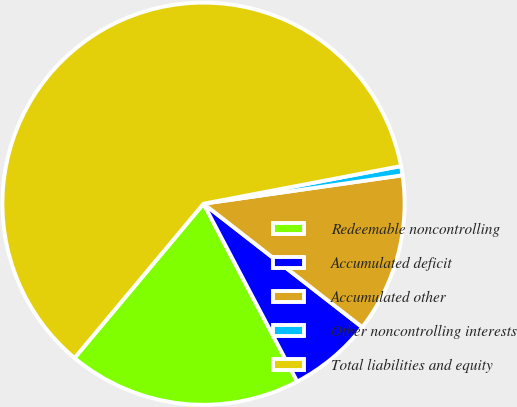Convert chart. <chart><loc_0><loc_0><loc_500><loc_500><pie_chart><fcel>Redeemable noncontrolling<fcel>Accumulated deficit<fcel>Accumulated other<fcel>Other noncontrolling interests<fcel>Total liabilities and equity<nl><fcel>18.8%<fcel>6.76%<fcel>12.78%<fcel>0.74%<fcel>60.92%<nl></chart> 